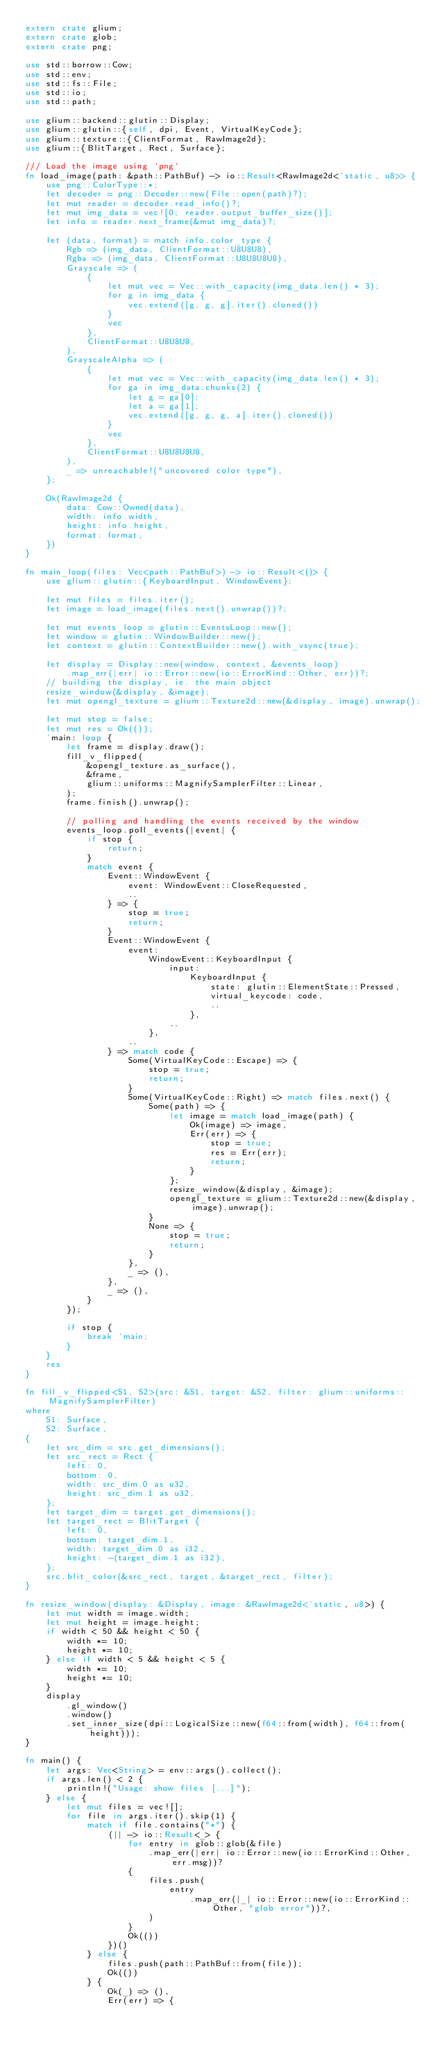Convert code to text. <code><loc_0><loc_0><loc_500><loc_500><_Rust_>extern crate glium;
extern crate glob;
extern crate png;

use std::borrow::Cow;
use std::env;
use std::fs::File;
use std::io;
use std::path;

use glium::backend::glutin::Display;
use glium::glutin::{self, dpi, Event, VirtualKeyCode};
use glium::texture::{ClientFormat, RawImage2d};
use glium::{BlitTarget, Rect, Surface};

/// Load the image using `png`
fn load_image(path: &path::PathBuf) -> io::Result<RawImage2d<'static, u8>> {
    use png::ColorType::*;
    let decoder = png::Decoder::new(File::open(path)?);
    let mut reader = decoder.read_info()?;
    let mut img_data = vec![0; reader.output_buffer_size()];
    let info = reader.next_frame(&mut img_data)?;

    let (data, format) = match info.color_type {
        Rgb => (img_data, ClientFormat::U8U8U8),
        Rgba => (img_data, ClientFormat::U8U8U8U8),
        Grayscale => (
            {
                let mut vec = Vec::with_capacity(img_data.len() * 3);
                for g in img_data {
                    vec.extend([g, g, g].iter().cloned())
                }
                vec
            },
            ClientFormat::U8U8U8,
        ),
        GrayscaleAlpha => (
            {
                let mut vec = Vec::with_capacity(img_data.len() * 3);
                for ga in img_data.chunks(2) {
                    let g = ga[0];
                    let a = ga[1];
                    vec.extend([g, g, g, a].iter().cloned())
                }
                vec
            },
            ClientFormat::U8U8U8U8,
        ),
        _ => unreachable!("uncovered color type"),
    };

    Ok(RawImage2d {
        data: Cow::Owned(data),
        width: info.width,
        height: info.height,
        format: format,
    })
}

fn main_loop(files: Vec<path::PathBuf>) -> io::Result<()> {
    use glium::glutin::{KeyboardInput, WindowEvent};

    let mut files = files.iter();
    let image = load_image(files.next().unwrap())?;

    let mut events_loop = glutin::EventsLoop::new();
    let window = glutin::WindowBuilder::new();
    let context = glutin::ContextBuilder::new().with_vsync(true);

    let display = Display::new(window, context, &events_loop)
        .map_err(|err| io::Error::new(io::ErrorKind::Other, err))?;
    // building the display, ie. the main object
    resize_window(&display, &image);
    let mut opengl_texture = glium::Texture2d::new(&display, image).unwrap();

    let mut stop = false;
    let mut res = Ok(());
    'main: loop {
        let frame = display.draw();
        fill_v_flipped(
            &opengl_texture.as_surface(),
            &frame,
            glium::uniforms::MagnifySamplerFilter::Linear,
        );
        frame.finish().unwrap();

        // polling and handling the events received by the window
        events_loop.poll_events(|event| {
            if stop {
                return;
            }
            match event {
                Event::WindowEvent {
                    event: WindowEvent::CloseRequested,
                    ..
                } => {
                    stop = true;
                    return;
                }
                Event::WindowEvent {
                    event:
                        WindowEvent::KeyboardInput {
                            input:
                                KeyboardInput {
                                    state: glutin::ElementState::Pressed,
                                    virtual_keycode: code,
                                    ..
                                },
                            ..
                        },
                    ..
                } => match code {
                    Some(VirtualKeyCode::Escape) => {
                        stop = true;
                        return;
                    }
                    Some(VirtualKeyCode::Right) => match files.next() {
                        Some(path) => {
                            let image = match load_image(path) {
                                Ok(image) => image,
                                Err(err) => {
                                    stop = true;
                                    res = Err(err);
                                    return;
                                }
                            };
                            resize_window(&display, &image);
                            opengl_texture = glium::Texture2d::new(&display, image).unwrap();
                        }
                        None => {
                            stop = true;
                            return;
                        }
                    },
                    _ => (),
                },
                _ => (),
            }
        });

        if stop {
            break 'main;
        }
    }
    res
}

fn fill_v_flipped<S1, S2>(src: &S1, target: &S2, filter: glium::uniforms::MagnifySamplerFilter)
where
    S1: Surface,
    S2: Surface,
{
    let src_dim = src.get_dimensions();
    let src_rect = Rect {
        left: 0,
        bottom: 0,
        width: src_dim.0 as u32,
        height: src_dim.1 as u32,
    };
    let target_dim = target.get_dimensions();
    let target_rect = BlitTarget {
        left: 0,
        bottom: target_dim.1,
        width: target_dim.0 as i32,
        height: -(target_dim.1 as i32),
    };
    src.blit_color(&src_rect, target, &target_rect, filter);
}

fn resize_window(display: &Display, image: &RawImage2d<'static, u8>) {
    let mut width = image.width;
    let mut height = image.height;
    if width < 50 && height < 50 {
        width *= 10;
        height *= 10;
    } else if width < 5 && height < 5 {
        width *= 10;
        height *= 10;
    }
    display
        .gl_window()
        .window()
        .set_inner_size(dpi::LogicalSize::new(f64::from(width), f64::from(height)));
}

fn main() {
    let args: Vec<String> = env::args().collect();
    if args.len() < 2 {
        println!("Usage: show files [...]");
    } else {
        let mut files = vec![];
        for file in args.iter().skip(1) {
            match if file.contains("*") {
                (|| -> io::Result<_> {
                    for entry in glob::glob(&file)
                        .map_err(|err| io::Error::new(io::ErrorKind::Other, err.msg))?
                    {
                        files.push(
                            entry
                                .map_err(|_| io::Error::new(io::ErrorKind::Other, "glob error"))?,
                        )
                    }
                    Ok(())
                })()
            } else {
                files.push(path::PathBuf::from(file));
                Ok(())
            } {
                Ok(_) => (),
                Err(err) => {</code> 